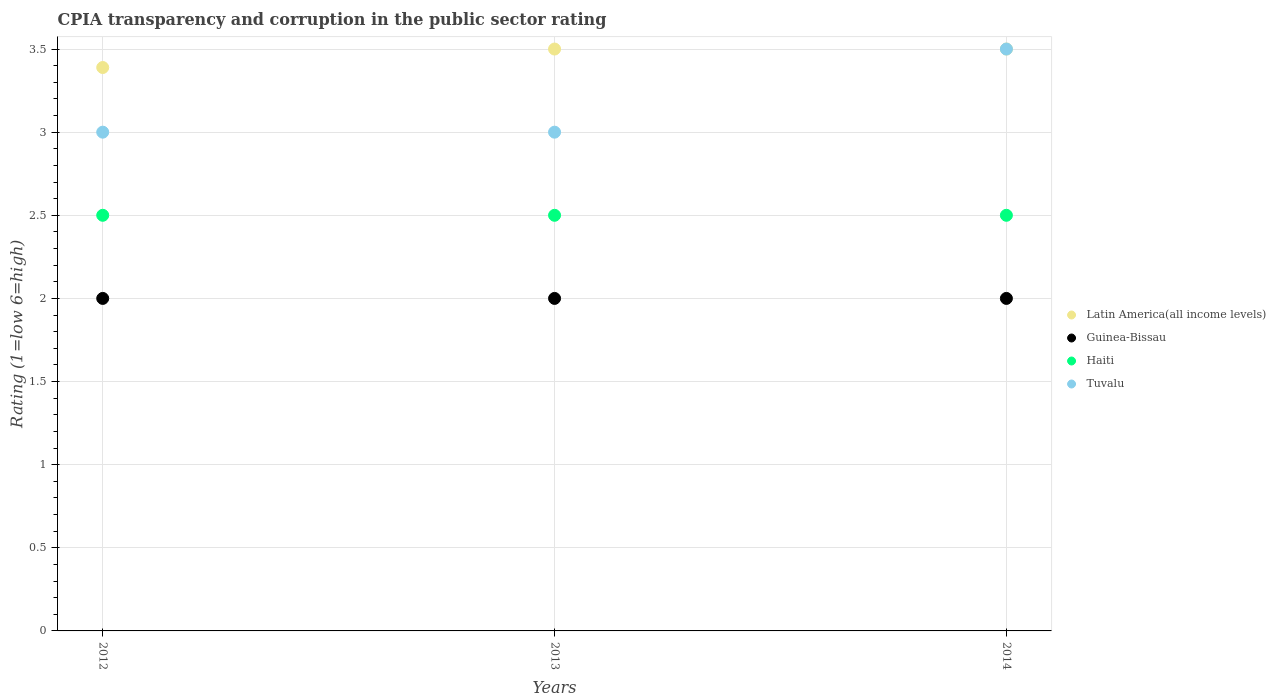How many different coloured dotlines are there?
Provide a succinct answer. 4. Is the number of dotlines equal to the number of legend labels?
Offer a very short reply. Yes. Across all years, what is the maximum CPIA rating in Haiti?
Provide a succinct answer. 2.5. Across all years, what is the minimum CPIA rating in Tuvalu?
Offer a very short reply. 3. In which year was the CPIA rating in Guinea-Bissau maximum?
Offer a very short reply. 2012. What is the total CPIA rating in Haiti in the graph?
Your answer should be compact. 7.5. What is the difference between the CPIA rating in Tuvalu in 2013 and the CPIA rating in Guinea-Bissau in 2012?
Your answer should be very brief. 1. In the year 2012, what is the difference between the CPIA rating in Latin America(all income levels) and CPIA rating in Haiti?
Make the answer very short. 0.89. What is the ratio of the CPIA rating in Tuvalu in 2013 to that in 2014?
Offer a terse response. 0.86. Is the difference between the CPIA rating in Latin America(all income levels) in 2012 and 2014 greater than the difference between the CPIA rating in Haiti in 2012 and 2014?
Keep it short and to the point. No. What is the difference between the highest and the lowest CPIA rating in Guinea-Bissau?
Make the answer very short. 0. Is it the case that in every year, the sum of the CPIA rating in Latin America(all income levels) and CPIA rating in Tuvalu  is greater than the sum of CPIA rating in Guinea-Bissau and CPIA rating in Haiti?
Give a very brief answer. Yes. Is it the case that in every year, the sum of the CPIA rating in Latin America(all income levels) and CPIA rating in Haiti  is greater than the CPIA rating in Tuvalu?
Ensure brevity in your answer.  Yes. Does the CPIA rating in Tuvalu monotonically increase over the years?
Offer a terse response. No. Is the CPIA rating in Guinea-Bissau strictly less than the CPIA rating in Haiti over the years?
Your answer should be compact. Yes. How many dotlines are there?
Ensure brevity in your answer.  4. Are the values on the major ticks of Y-axis written in scientific E-notation?
Keep it short and to the point. No. Does the graph contain any zero values?
Your response must be concise. No. Where does the legend appear in the graph?
Keep it short and to the point. Center right. How many legend labels are there?
Your response must be concise. 4. How are the legend labels stacked?
Offer a terse response. Vertical. What is the title of the graph?
Your response must be concise. CPIA transparency and corruption in the public sector rating. What is the label or title of the X-axis?
Keep it short and to the point. Years. What is the Rating (1=low 6=high) of Latin America(all income levels) in 2012?
Offer a very short reply. 3.39. What is the Rating (1=low 6=high) of Tuvalu in 2012?
Your response must be concise. 3. What is the Rating (1=low 6=high) in Tuvalu in 2013?
Keep it short and to the point. 3. What is the Rating (1=low 6=high) of Latin America(all income levels) in 2014?
Your answer should be compact. 3.5. Across all years, what is the maximum Rating (1=low 6=high) of Guinea-Bissau?
Give a very brief answer. 2. Across all years, what is the minimum Rating (1=low 6=high) of Latin America(all income levels)?
Your answer should be very brief. 3.39. Across all years, what is the minimum Rating (1=low 6=high) of Guinea-Bissau?
Provide a short and direct response. 2. Across all years, what is the minimum Rating (1=low 6=high) of Haiti?
Give a very brief answer. 2.5. What is the total Rating (1=low 6=high) in Latin America(all income levels) in the graph?
Provide a short and direct response. 10.39. What is the total Rating (1=low 6=high) in Guinea-Bissau in the graph?
Ensure brevity in your answer.  6. What is the total Rating (1=low 6=high) of Tuvalu in the graph?
Keep it short and to the point. 9.5. What is the difference between the Rating (1=low 6=high) of Latin America(all income levels) in 2012 and that in 2013?
Offer a terse response. -0.11. What is the difference between the Rating (1=low 6=high) in Guinea-Bissau in 2012 and that in 2013?
Keep it short and to the point. 0. What is the difference between the Rating (1=low 6=high) in Haiti in 2012 and that in 2013?
Offer a very short reply. 0. What is the difference between the Rating (1=low 6=high) of Latin America(all income levels) in 2012 and that in 2014?
Your answer should be compact. -0.11. What is the difference between the Rating (1=low 6=high) in Latin America(all income levels) in 2013 and that in 2014?
Give a very brief answer. 0. What is the difference between the Rating (1=low 6=high) in Guinea-Bissau in 2013 and that in 2014?
Ensure brevity in your answer.  0. What is the difference between the Rating (1=low 6=high) of Haiti in 2013 and that in 2014?
Provide a short and direct response. 0. What is the difference between the Rating (1=low 6=high) in Latin America(all income levels) in 2012 and the Rating (1=low 6=high) in Guinea-Bissau in 2013?
Provide a succinct answer. 1.39. What is the difference between the Rating (1=low 6=high) of Latin America(all income levels) in 2012 and the Rating (1=low 6=high) of Tuvalu in 2013?
Your answer should be very brief. 0.39. What is the difference between the Rating (1=low 6=high) of Guinea-Bissau in 2012 and the Rating (1=low 6=high) of Haiti in 2013?
Provide a short and direct response. -0.5. What is the difference between the Rating (1=low 6=high) in Latin America(all income levels) in 2012 and the Rating (1=low 6=high) in Guinea-Bissau in 2014?
Your answer should be compact. 1.39. What is the difference between the Rating (1=low 6=high) in Latin America(all income levels) in 2012 and the Rating (1=low 6=high) in Tuvalu in 2014?
Offer a very short reply. -0.11. What is the difference between the Rating (1=low 6=high) in Latin America(all income levels) in 2013 and the Rating (1=low 6=high) in Guinea-Bissau in 2014?
Your answer should be compact. 1.5. What is the difference between the Rating (1=low 6=high) in Latin America(all income levels) in 2013 and the Rating (1=low 6=high) in Haiti in 2014?
Provide a succinct answer. 1. What is the difference between the Rating (1=low 6=high) of Guinea-Bissau in 2013 and the Rating (1=low 6=high) of Tuvalu in 2014?
Offer a terse response. -1.5. What is the average Rating (1=low 6=high) of Latin America(all income levels) per year?
Make the answer very short. 3.46. What is the average Rating (1=low 6=high) in Haiti per year?
Provide a short and direct response. 2.5. What is the average Rating (1=low 6=high) of Tuvalu per year?
Give a very brief answer. 3.17. In the year 2012, what is the difference between the Rating (1=low 6=high) of Latin America(all income levels) and Rating (1=low 6=high) of Guinea-Bissau?
Provide a succinct answer. 1.39. In the year 2012, what is the difference between the Rating (1=low 6=high) of Latin America(all income levels) and Rating (1=low 6=high) of Haiti?
Your response must be concise. 0.89. In the year 2012, what is the difference between the Rating (1=low 6=high) in Latin America(all income levels) and Rating (1=low 6=high) in Tuvalu?
Keep it short and to the point. 0.39. In the year 2012, what is the difference between the Rating (1=low 6=high) in Guinea-Bissau and Rating (1=low 6=high) in Tuvalu?
Ensure brevity in your answer.  -1. In the year 2012, what is the difference between the Rating (1=low 6=high) of Haiti and Rating (1=low 6=high) of Tuvalu?
Provide a short and direct response. -0.5. In the year 2013, what is the difference between the Rating (1=low 6=high) of Latin America(all income levels) and Rating (1=low 6=high) of Guinea-Bissau?
Keep it short and to the point. 1.5. In the year 2013, what is the difference between the Rating (1=low 6=high) in Guinea-Bissau and Rating (1=low 6=high) in Haiti?
Provide a succinct answer. -0.5. In the year 2013, what is the difference between the Rating (1=low 6=high) in Haiti and Rating (1=low 6=high) in Tuvalu?
Provide a succinct answer. -0.5. In the year 2014, what is the difference between the Rating (1=low 6=high) in Latin America(all income levels) and Rating (1=low 6=high) in Guinea-Bissau?
Offer a terse response. 1.5. In the year 2014, what is the difference between the Rating (1=low 6=high) in Latin America(all income levels) and Rating (1=low 6=high) in Tuvalu?
Make the answer very short. 0. In the year 2014, what is the difference between the Rating (1=low 6=high) of Guinea-Bissau and Rating (1=low 6=high) of Tuvalu?
Make the answer very short. -1.5. In the year 2014, what is the difference between the Rating (1=low 6=high) in Haiti and Rating (1=low 6=high) in Tuvalu?
Offer a very short reply. -1. What is the ratio of the Rating (1=low 6=high) of Latin America(all income levels) in 2012 to that in 2013?
Offer a terse response. 0.97. What is the ratio of the Rating (1=low 6=high) in Guinea-Bissau in 2012 to that in 2013?
Your answer should be very brief. 1. What is the ratio of the Rating (1=low 6=high) of Tuvalu in 2012 to that in 2013?
Provide a succinct answer. 1. What is the ratio of the Rating (1=low 6=high) in Latin America(all income levels) in 2012 to that in 2014?
Ensure brevity in your answer.  0.97. What is the ratio of the Rating (1=low 6=high) in Guinea-Bissau in 2012 to that in 2014?
Offer a very short reply. 1. What is the ratio of the Rating (1=low 6=high) in Latin America(all income levels) in 2013 to that in 2014?
Your answer should be very brief. 1. What is the ratio of the Rating (1=low 6=high) in Haiti in 2013 to that in 2014?
Your answer should be compact. 1. What is the ratio of the Rating (1=low 6=high) of Tuvalu in 2013 to that in 2014?
Your answer should be very brief. 0.86. What is the difference between the highest and the second highest Rating (1=low 6=high) in Guinea-Bissau?
Offer a very short reply. 0. What is the difference between the highest and the second highest Rating (1=low 6=high) in Haiti?
Your answer should be compact. 0. What is the difference between the highest and the second highest Rating (1=low 6=high) of Tuvalu?
Offer a terse response. 0.5. What is the difference between the highest and the lowest Rating (1=low 6=high) in Haiti?
Ensure brevity in your answer.  0. What is the difference between the highest and the lowest Rating (1=low 6=high) of Tuvalu?
Offer a very short reply. 0.5. 